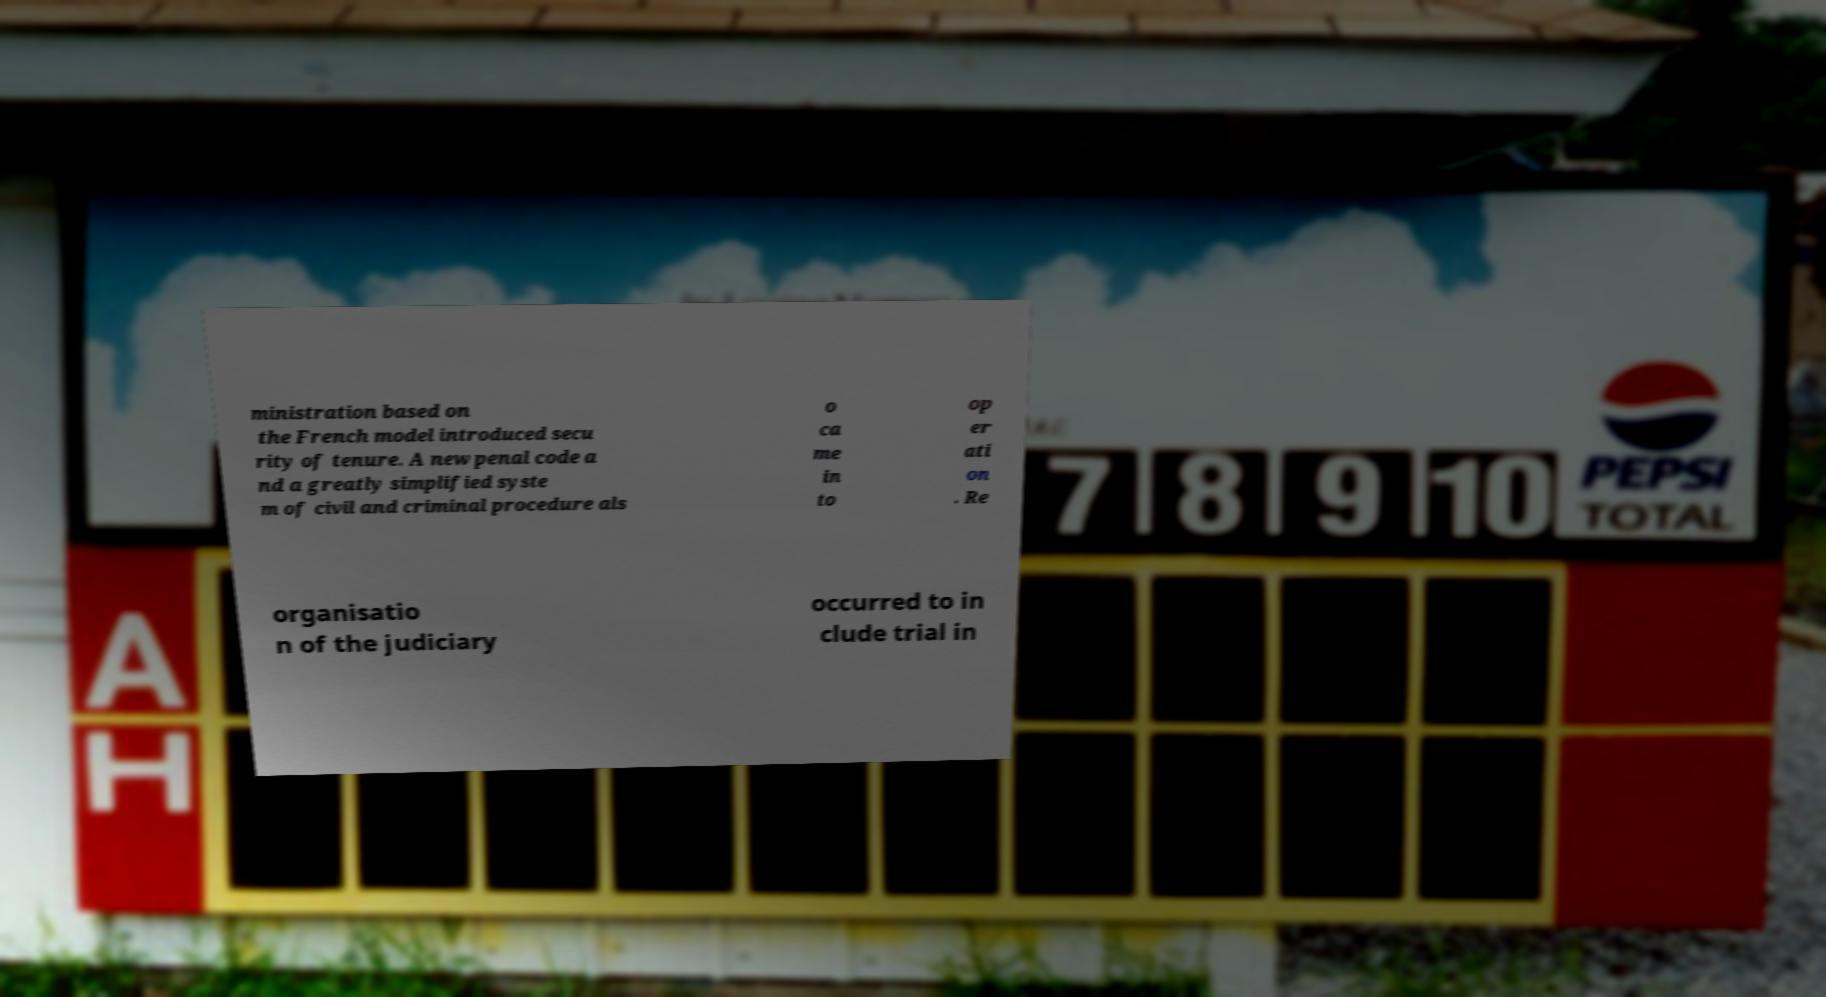Please read and relay the text visible in this image. What does it say? ministration based on the French model introduced secu rity of tenure. A new penal code a nd a greatly simplified syste m of civil and criminal procedure als o ca me in to op er ati on . Re organisatio n of the judiciary occurred to in clude trial in 